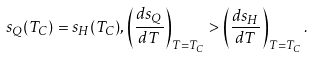<formula> <loc_0><loc_0><loc_500><loc_500>s _ { Q } ( T _ { C } ) = s _ { H } ( T _ { C } ) , \left ( \frac { d s _ { Q } } { d T } \right ) _ { T = T _ { C } } > \left ( \frac { d s _ { H } } { d T } \right ) _ { T = T _ { C } } .</formula> 